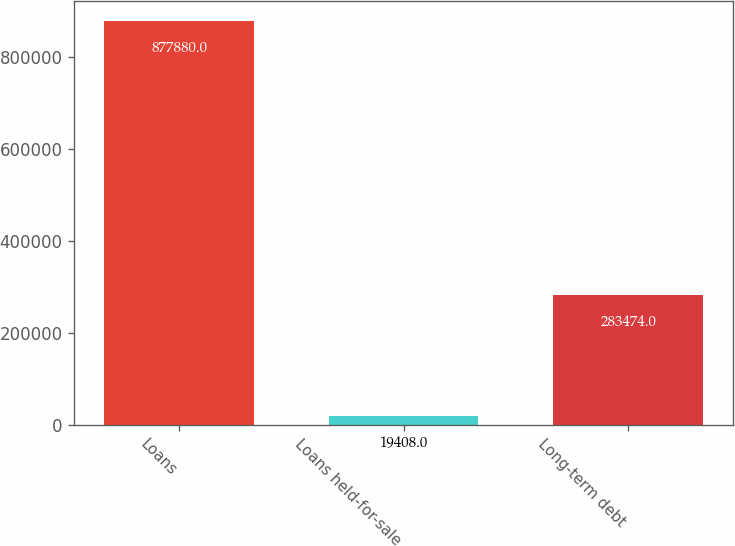<chart> <loc_0><loc_0><loc_500><loc_500><bar_chart><fcel>Loans<fcel>Loans held-for-sale<fcel>Long-term debt<nl><fcel>877880<fcel>19408<fcel>283474<nl></chart> 